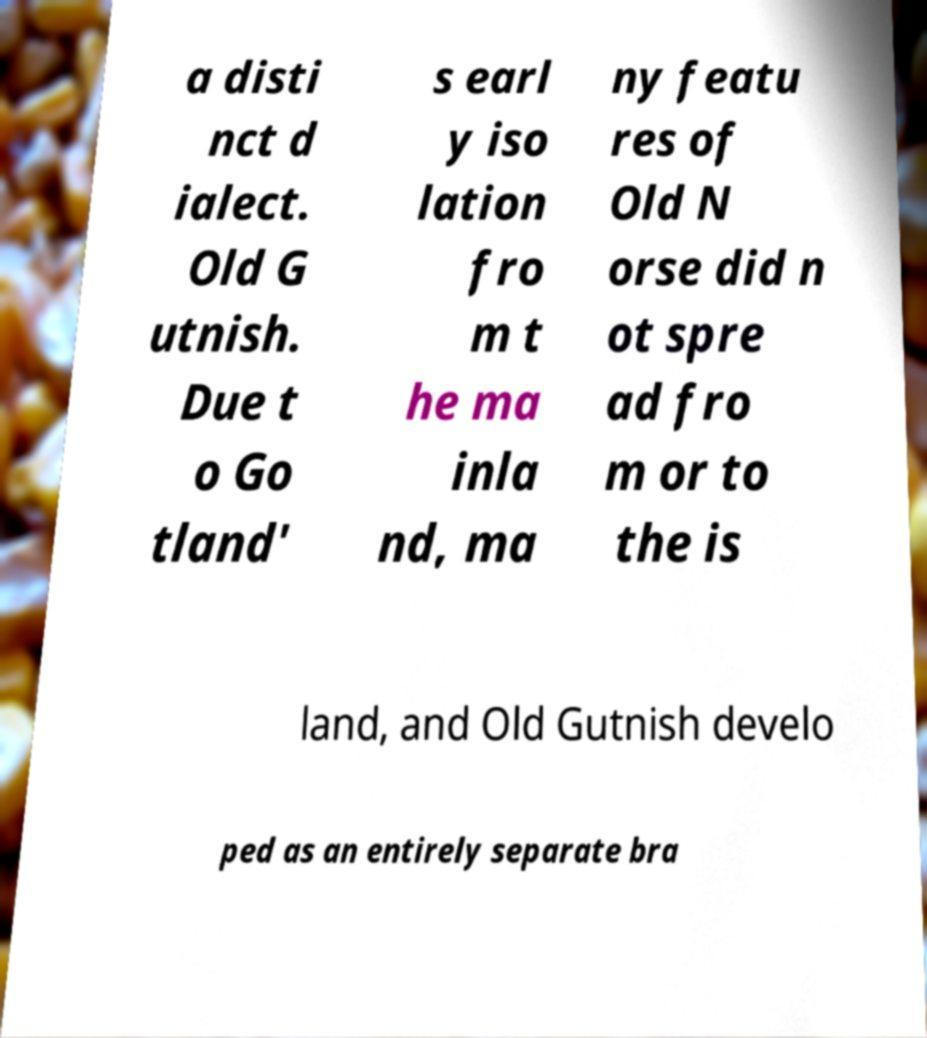Could you assist in decoding the text presented in this image and type it out clearly? a disti nct d ialect. Old G utnish. Due t o Go tland' s earl y iso lation fro m t he ma inla nd, ma ny featu res of Old N orse did n ot spre ad fro m or to the is land, and Old Gutnish develo ped as an entirely separate bra 